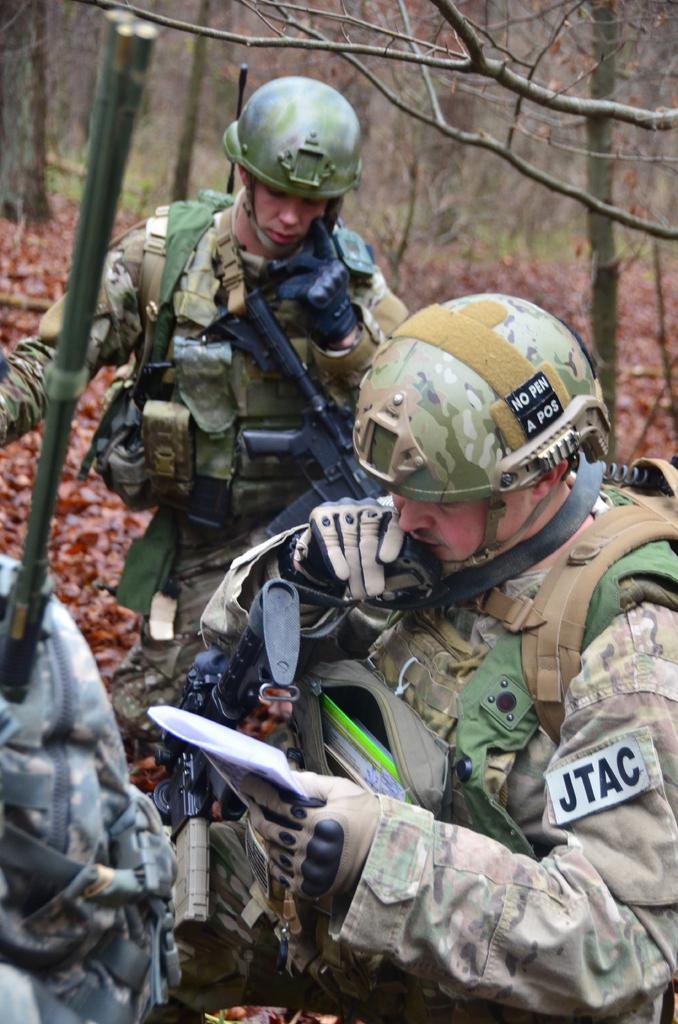Can you describe this image briefly? In the foreground of this image, there are three people wearing military dress, helmets, jackets, bag packs and also holding guns. There is a man holding a bag, paper and talking to a walkie-talkie. In the background, there are trees and the dry leaves. 